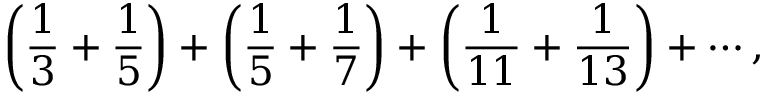<formula> <loc_0><loc_0><loc_500><loc_500>\left ( { { \frac { 1 } { 3 } } + { \frac { 1 } { 5 } } } \right ) + \left ( { { \frac { 1 } { 5 } } + { \frac { 1 } { 7 } } } \right ) + \left ( { { \frac { 1 } { 1 1 } } + { \frac { 1 } { 1 3 } } } \right ) + \cdots ,</formula> 